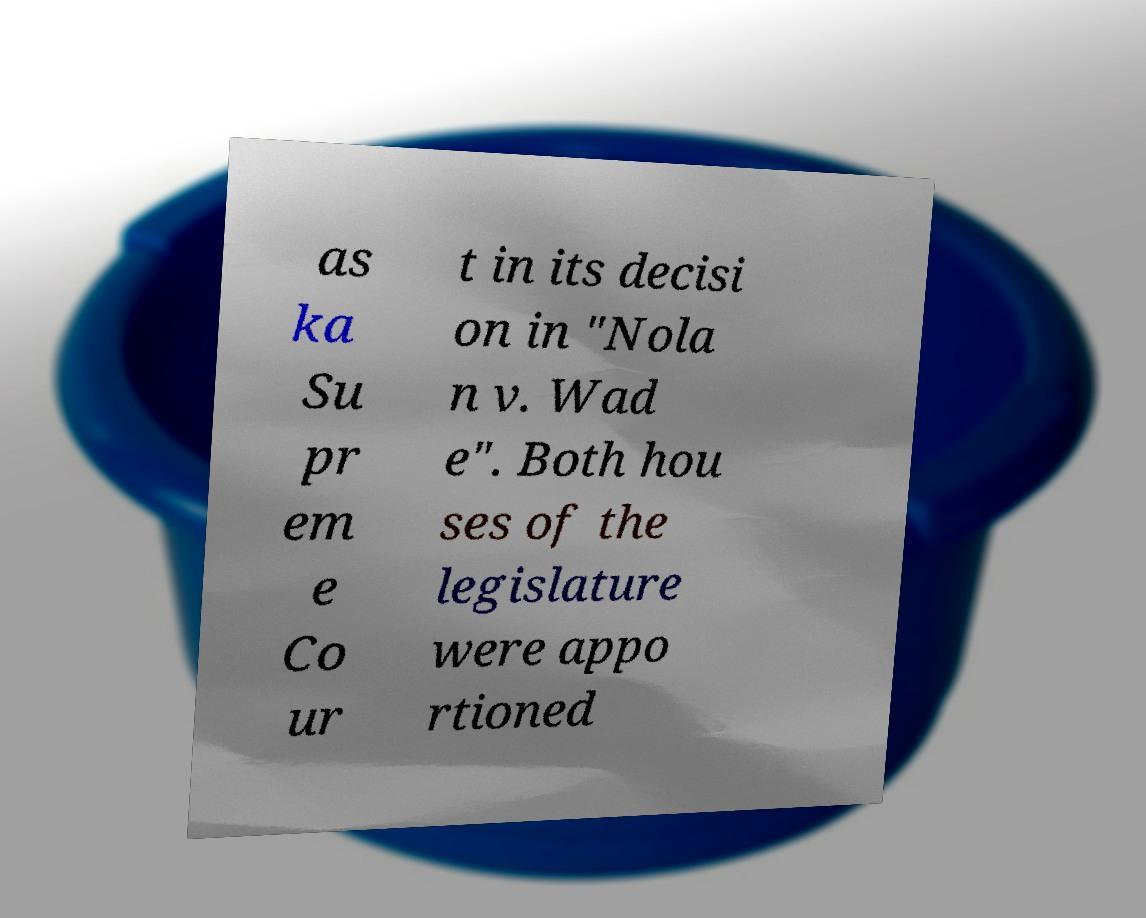For documentation purposes, I need the text within this image transcribed. Could you provide that? as ka Su pr em e Co ur t in its decisi on in "Nola n v. Wad e". Both hou ses of the legislature were appo rtioned 